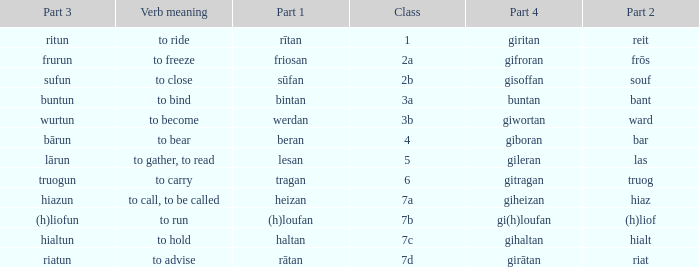What is the part 4 of the word with the part 1 "heizan"? Giheizan. 